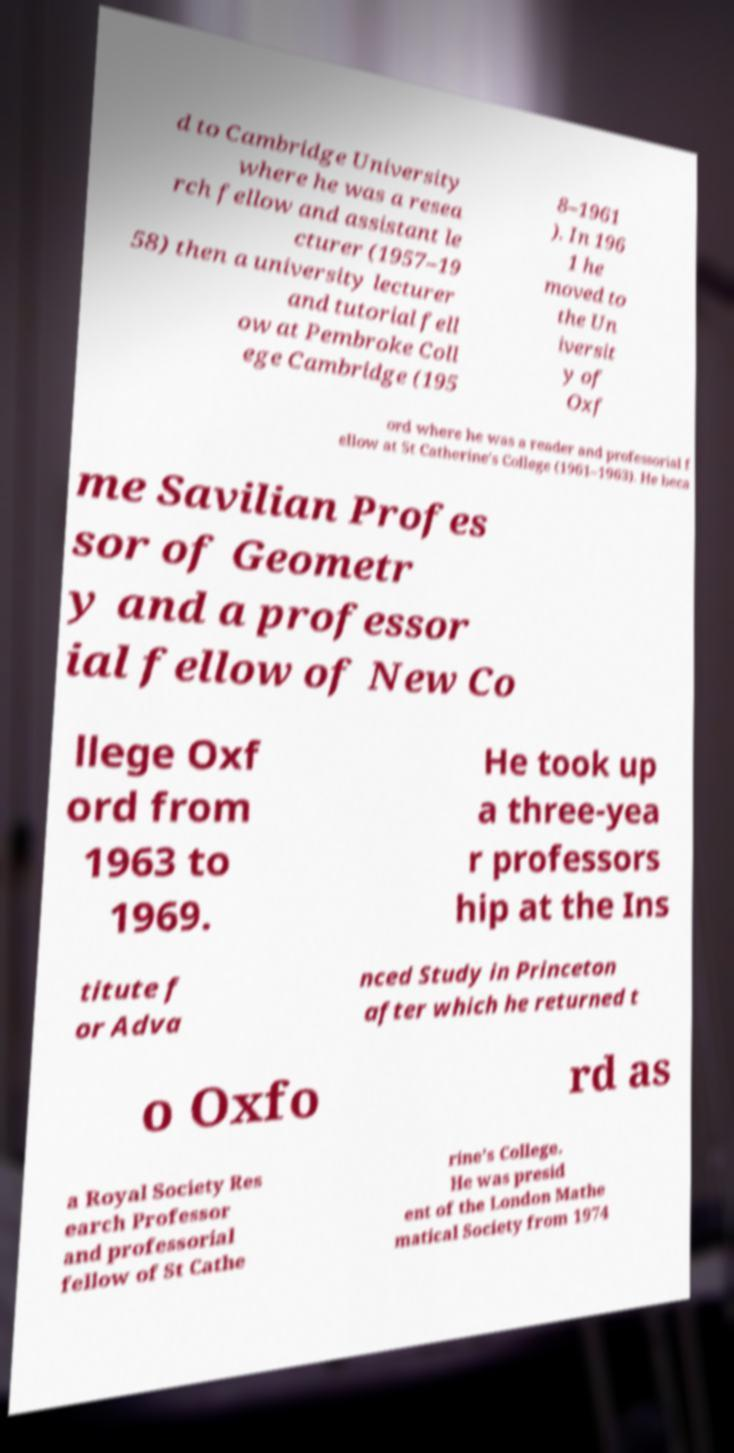There's text embedded in this image that I need extracted. Can you transcribe it verbatim? d to Cambridge University where he was a resea rch fellow and assistant le cturer (1957–19 58) then a university lecturer and tutorial fell ow at Pembroke Coll ege Cambridge (195 8–1961 ). In 196 1 he moved to the Un iversit y of Oxf ord where he was a reader and professorial f ellow at St Catherine's College (1961–1963). He beca me Savilian Profes sor of Geometr y and a professor ial fellow of New Co llege Oxf ord from 1963 to 1969. He took up a three-yea r professors hip at the Ins titute f or Adva nced Study in Princeton after which he returned t o Oxfo rd as a Royal Society Res earch Professor and professorial fellow of St Cathe rine's College. He was presid ent of the London Mathe matical Society from 1974 